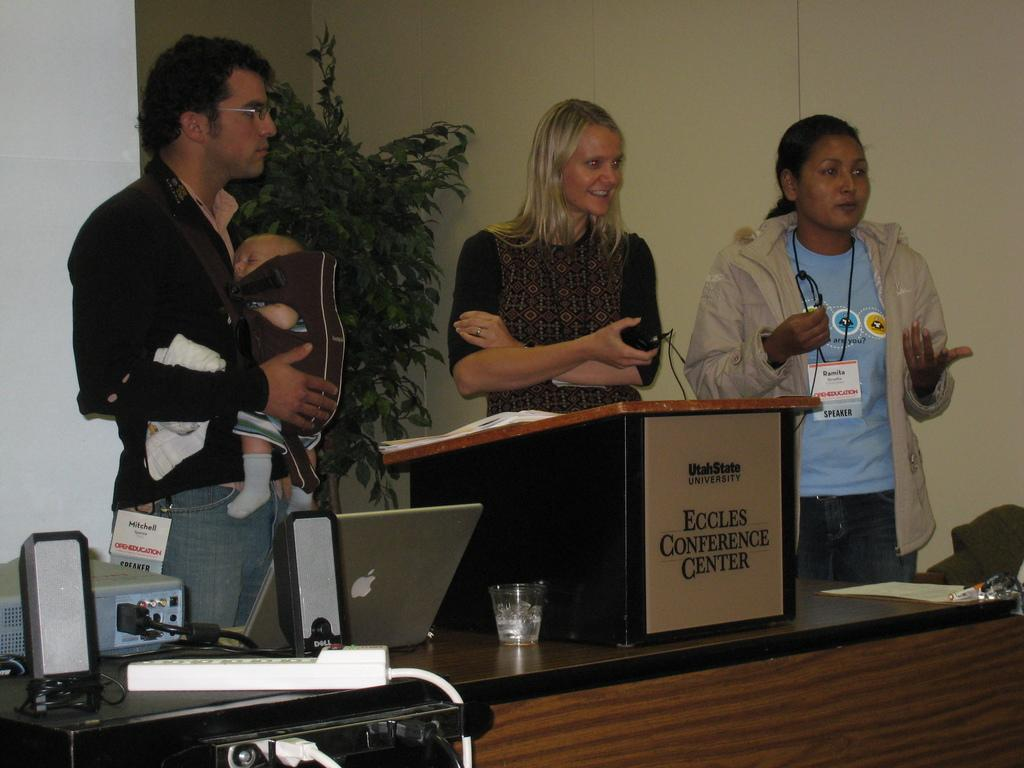How many people are present in the image? There are three people in the image. What are the people doing in the image? The people are standing. What objects can be seen on the table in the image? There is a laptop, a glass, a projector, and a switch board on the table. What type of toys are being played with on the table in the image? There are no toys present in the image; the objects on the table include a laptop, a glass, a projector, and a switch board. What color of paint is being used by the people in the image? There is no paint or painting activity depicted in the image; the people are simply standing. 